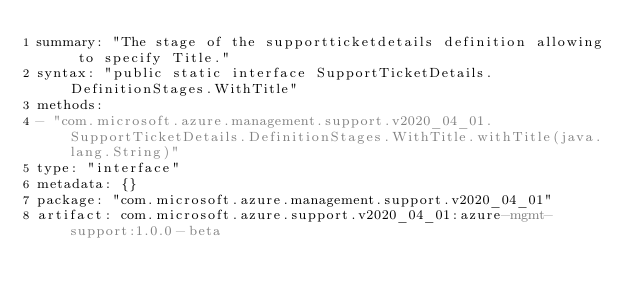<code> <loc_0><loc_0><loc_500><loc_500><_YAML_>summary: "The stage of the supportticketdetails definition allowing to specify Title."
syntax: "public static interface SupportTicketDetails.DefinitionStages.WithTitle"
methods:
- "com.microsoft.azure.management.support.v2020_04_01.SupportTicketDetails.DefinitionStages.WithTitle.withTitle(java.lang.String)"
type: "interface"
metadata: {}
package: "com.microsoft.azure.management.support.v2020_04_01"
artifact: com.microsoft.azure.support.v2020_04_01:azure-mgmt-support:1.0.0-beta
</code> 